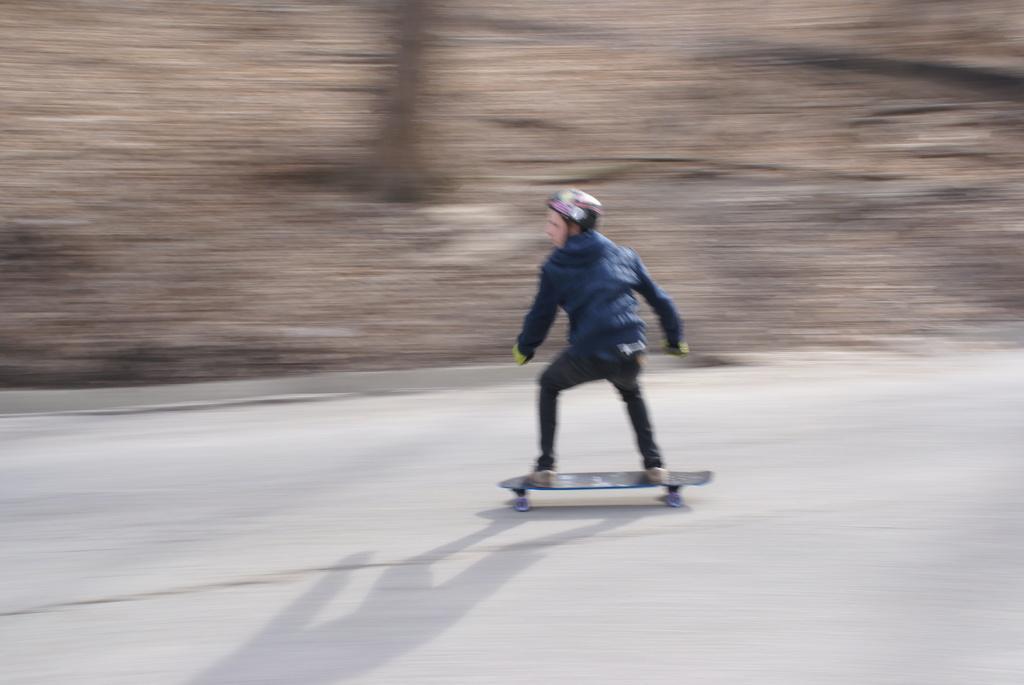Could you give a brief overview of what you see in this image? In the image there is a person with a helmet on his head. He is standing on the skateboard and skating on the road. Behind him there is a blur background. 